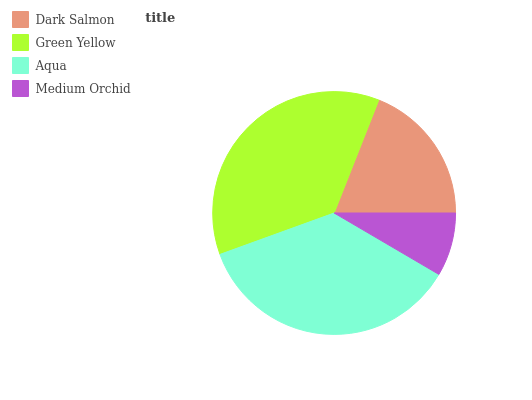Is Medium Orchid the minimum?
Answer yes or no. Yes. Is Green Yellow the maximum?
Answer yes or no. Yes. Is Aqua the minimum?
Answer yes or no. No. Is Aqua the maximum?
Answer yes or no. No. Is Green Yellow greater than Aqua?
Answer yes or no. Yes. Is Aqua less than Green Yellow?
Answer yes or no. Yes. Is Aqua greater than Green Yellow?
Answer yes or no. No. Is Green Yellow less than Aqua?
Answer yes or no. No. Is Aqua the high median?
Answer yes or no. Yes. Is Dark Salmon the low median?
Answer yes or no. Yes. Is Medium Orchid the high median?
Answer yes or no. No. Is Medium Orchid the low median?
Answer yes or no. No. 